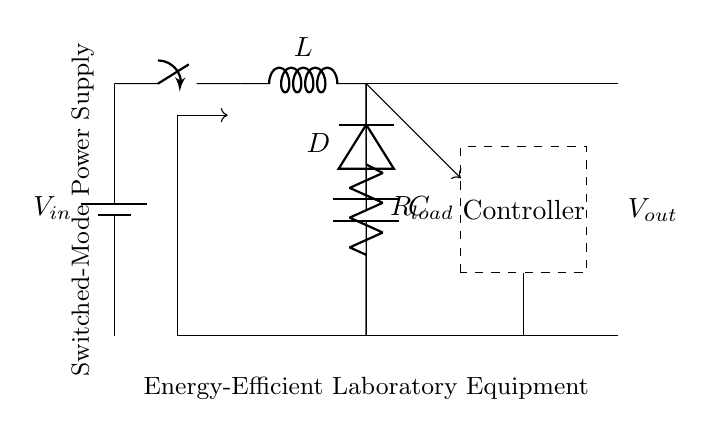What is the function of the switch in this circuit? The switch opens or closes the path for current, controlling the power delivered to the load. In switched-mode power supplies, it is crucial to switch rapidly to manage energy efficiently.
Answer: Control current What is the role of the inductor in this circuit? The inductor stores energy in a magnetic field when current flows through it and releases it when the current path is cut off, helping to maintain a stable output voltage.
Answer: Energy storage What type of diode is used in this circuit? The circuit specifies a diode, commonly indicating a rectifier diode which allows current to flow in one direction, crucial for converting AC to DC in power supplies.
Answer: Rectifier diode What is the purpose of the capacitor in the circuit? The capacitor smooths the output voltage by filtering out voltage spikes and providing a stable DC output, acting as a reservoir of charge.
Answer: Voltage filtering What is the output voltage of this circuit assumed to be? The output voltage is not explicitly labeled, but it typically would be a controlled value set by the feedback to maintain regulation for the load.
Answer: Regulated voltage What component is responsible for controlling the output voltage? The component labeled as 'Controller' manages the switch based on feedback from the output voltage to maintain desired output levels.
Answer: Controller What type of power supply does this circuit represent? The circuit diagram indicates a switched-mode power supply, which is designed for higher efficiency by rapidly switching the input current on and off.
Answer: Switched-mode power supply 